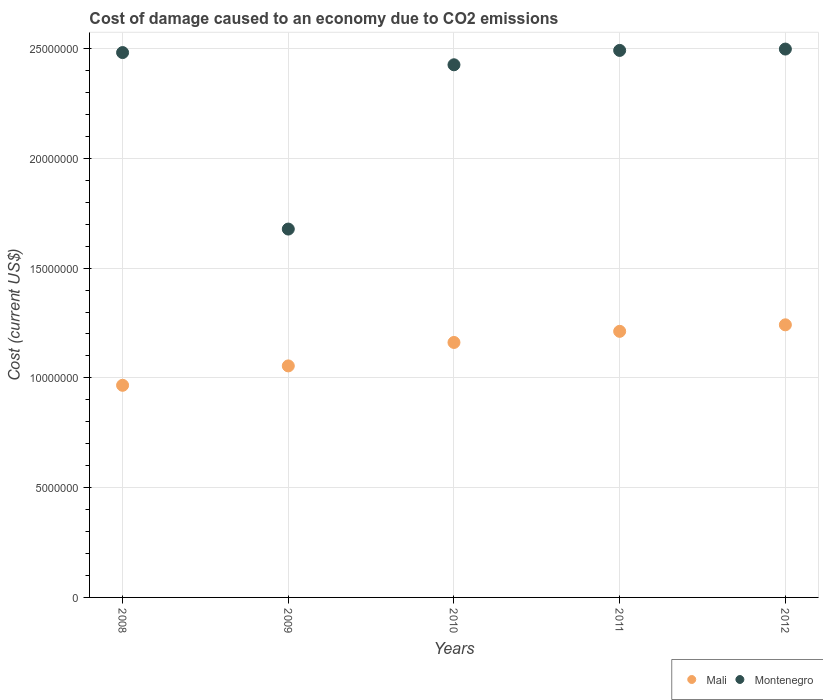How many different coloured dotlines are there?
Keep it short and to the point. 2. Is the number of dotlines equal to the number of legend labels?
Ensure brevity in your answer.  Yes. What is the cost of damage caused due to CO2 emissisons in Mali in 2012?
Keep it short and to the point. 1.24e+07. Across all years, what is the maximum cost of damage caused due to CO2 emissisons in Mali?
Ensure brevity in your answer.  1.24e+07. Across all years, what is the minimum cost of damage caused due to CO2 emissisons in Montenegro?
Provide a short and direct response. 1.68e+07. What is the total cost of damage caused due to CO2 emissisons in Montenegro in the graph?
Ensure brevity in your answer.  1.16e+08. What is the difference between the cost of damage caused due to CO2 emissisons in Montenegro in 2009 and that in 2012?
Make the answer very short. -8.20e+06. What is the difference between the cost of damage caused due to CO2 emissisons in Mali in 2011 and the cost of damage caused due to CO2 emissisons in Montenegro in 2009?
Your answer should be compact. -4.66e+06. What is the average cost of damage caused due to CO2 emissisons in Montenegro per year?
Offer a very short reply. 2.32e+07. In the year 2008, what is the difference between the cost of damage caused due to CO2 emissisons in Mali and cost of damage caused due to CO2 emissisons in Montenegro?
Give a very brief answer. -1.52e+07. In how many years, is the cost of damage caused due to CO2 emissisons in Mali greater than 9000000 US$?
Offer a very short reply. 5. What is the ratio of the cost of damage caused due to CO2 emissisons in Montenegro in 2008 to that in 2011?
Provide a short and direct response. 1. Is the cost of damage caused due to CO2 emissisons in Mali in 2008 less than that in 2009?
Make the answer very short. Yes. What is the difference between the highest and the second highest cost of damage caused due to CO2 emissisons in Montenegro?
Provide a succinct answer. 6.16e+04. What is the difference between the highest and the lowest cost of damage caused due to CO2 emissisons in Montenegro?
Offer a terse response. 8.20e+06. In how many years, is the cost of damage caused due to CO2 emissisons in Montenegro greater than the average cost of damage caused due to CO2 emissisons in Montenegro taken over all years?
Ensure brevity in your answer.  4. Does the cost of damage caused due to CO2 emissisons in Montenegro monotonically increase over the years?
Provide a short and direct response. No. Is the cost of damage caused due to CO2 emissisons in Montenegro strictly less than the cost of damage caused due to CO2 emissisons in Mali over the years?
Provide a succinct answer. No. How many dotlines are there?
Ensure brevity in your answer.  2. Are the values on the major ticks of Y-axis written in scientific E-notation?
Give a very brief answer. No. Does the graph contain any zero values?
Give a very brief answer. No. Does the graph contain grids?
Your answer should be compact. Yes. Where does the legend appear in the graph?
Ensure brevity in your answer.  Bottom right. How many legend labels are there?
Offer a terse response. 2. How are the legend labels stacked?
Provide a succinct answer. Horizontal. What is the title of the graph?
Keep it short and to the point. Cost of damage caused to an economy due to CO2 emissions. What is the label or title of the Y-axis?
Offer a terse response. Cost (current US$). What is the Cost (current US$) in Mali in 2008?
Your response must be concise. 9.66e+06. What is the Cost (current US$) in Montenegro in 2008?
Ensure brevity in your answer.  2.48e+07. What is the Cost (current US$) of Mali in 2009?
Your response must be concise. 1.05e+07. What is the Cost (current US$) of Montenegro in 2009?
Provide a succinct answer. 1.68e+07. What is the Cost (current US$) in Mali in 2010?
Keep it short and to the point. 1.16e+07. What is the Cost (current US$) in Montenegro in 2010?
Offer a very short reply. 2.43e+07. What is the Cost (current US$) in Mali in 2011?
Keep it short and to the point. 1.21e+07. What is the Cost (current US$) of Montenegro in 2011?
Keep it short and to the point. 2.49e+07. What is the Cost (current US$) in Mali in 2012?
Offer a terse response. 1.24e+07. What is the Cost (current US$) in Montenegro in 2012?
Ensure brevity in your answer.  2.50e+07. Across all years, what is the maximum Cost (current US$) of Mali?
Provide a short and direct response. 1.24e+07. Across all years, what is the maximum Cost (current US$) in Montenegro?
Offer a very short reply. 2.50e+07. Across all years, what is the minimum Cost (current US$) of Mali?
Give a very brief answer. 9.66e+06. Across all years, what is the minimum Cost (current US$) of Montenegro?
Provide a succinct answer. 1.68e+07. What is the total Cost (current US$) of Mali in the graph?
Offer a very short reply. 5.64e+07. What is the total Cost (current US$) of Montenegro in the graph?
Your answer should be compact. 1.16e+08. What is the difference between the Cost (current US$) of Mali in 2008 and that in 2009?
Offer a terse response. -8.83e+05. What is the difference between the Cost (current US$) of Montenegro in 2008 and that in 2009?
Provide a succinct answer. 8.04e+06. What is the difference between the Cost (current US$) of Mali in 2008 and that in 2010?
Your answer should be compact. -1.95e+06. What is the difference between the Cost (current US$) of Montenegro in 2008 and that in 2010?
Give a very brief answer. 5.56e+05. What is the difference between the Cost (current US$) in Mali in 2008 and that in 2011?
Provide a succinct answer. -2.46e+06. What is the difference between the Cost (current US$) in Montenegro in 2008 and that in 2011?
Offer a terse response. -9.83e+04. What is the difference between the Cost (current US$) in Mali in 2008 and that in 2012?
Provide a short and direct response. -2.75e+06. What is the difference between the Cost (current US$) in Montenegro in 2008 and that in 2012?
Provide a short and direct response. -1.60e+05. What is the difference between the Cost (current US$) in Mali in 2009 and that in 2010?
Offer a very short reply. -1.07e+06. What is the difference between the Cost (current US$) in Montenegro in 2009 and that in 2010?
Offer a terse response. -7.48e+06. What is the difference between the Cost (current US$) of Mali in 2009 and that in 2011?
Your answer should be very brief. -1.57e+06. What is the difference between the Cost (current US$) in Montenegro in 2009 and that in 2011?
Provide a succinct answer. -8.14e+06. What is the difference between the Cost (current US$) of Mali in 2009 and that in 2012?
Provide a succinct answer. -1.87e+06. What is the difference between the Cost (current US$) in Montenegro in 2009 and that in 2012?
Offer a terse response. -8.20e+06. What is the difference between the Cost (current US$) of Mali in 2010 and that in 2011?
Your answer should be compact. -5.07e+05. What is the difference between the Cost (current US$) in Montenegro in 2010 and that in 2011?
Provide a succinct answer. -6.55e+05. What is the difference between the Cost (current US$) of Mali in 2010 and that in 2012?
Offer a terse response. -8.03e+05. What is the difference between the Cost (current US$) in Montenegro in 2010 and that in 2012?
Make the answer very short. -7.16e+05. What is the difference between the Cost (current US$) of Mali in 2011 and that in 2012?
Provide a short and direct response. -2.96e+05. What is the difference between the Cost (current US$) in Montenegro in 2011 and that in 2012?
Make the answer very short. -6.16e+04. What is the difference between the Cost (current US$) in Mali in 2008 and the Cost (current US$) in Montenegro in 2009?
Offer a very short reply. -7.12e+06. What is the difference between the Cost (current US$) in Mali in 2008 and the Cost (current US$) in Montenegro in 2010?
Make the answer very short. -1.46e+07. What is the difference between the Cost (current US$) in Mali in 2008 and the Cost (current US$) in Montenegro in 2011?
Your answer should be compact. -1.53e+07. What is the difference between the Cost (current US$) in Mali in 2008 and the Cost (current US$) in Montenegro in 2012?
Ensure brevity in your answer.  -1.53e+07. What is the difference between the Cost (current US$) of Mali in 2009 and the Cost (current US$) of Montenegro in 2010?
Make the answer very short. -1.37e+07. What is the difference between the Cost (current US$) in Mali in 2009 and the Cost (current US$) in Montenegro in 2011?
Keep it short and to the point. -1.44e+07. What is the difference between the Cost (current US$) of Mali in 2009 and the Cost (current US$) of Montenegro in 2012?
Keep it short and to the point. -1.44e+07. What is the difference between the Cost (current US$) in Mali in 2010 and the Cost (current US$) in Montenegro in 2011?
Keep it short and to the point. -1.33e+07. What is the difference between the Cost (current US$) of Mali in 2010 and the Cost (current US$) of Montenegro in 2012?
Ensure brevity in your answer.  -1.34e+07. What is the difference between the Cost (current US$) of Mali in 2011 and the Cost (current US$) of Montenegro in 2012?
Your answer should be very brief. -1.29e+07. What is the average Cost (current US$) in Mali per year?
Provide a succinct answer. 1.13e+07. What is the average Cost (current US$) in Montenegro per year?
Give a very brief answer. 2.32e+07. In the year 2008, what is the difference between the Cost (current US$) of Mali and Cost (current US$) of Montenegro?
Offer a terse response. -1.52e+07. In the year 2009, what is the difference between the Cost (current US$) of Mali and Cost (current US$) of Montenegro?
Give a very brief answer. -6.23e+06. In the year 2010, what is the difference between the Cost (current US$) of Mali and Cost (current US$) of Montenegro?
Ensure brevity in your answer.  -1.26e+07. In the year 2011, what is the difference between the Cost (current US$) in Mali and Cost (current US$) in Montenegro?
Your answer should be very brief. -1.28e+07. In the year 2012, what is the difference between the Cost (current US$) of Mali and Cost (current US$) of Montenegro?
Your response must be concise. -1.26e+07. What is the ratio of the Cost (current US$) in Mali in 2008 to that in 2009?
Provide a succinct answer. 0.92. What is the ratio of the Cost (current US$) in Montenegro in 2008 to that in 2009?
Provide a short and direct response. 1.48. What is the ratio of the Cost (current US$) in Mali in 2008 to that in 2010?
Your answer should be compact. 0.83. What is the ratio of the Cost (current US$) of Montenegro in 2008 to that in 2010?
Offer a terse response. 1.02. What is the ratio of the Cost (current US$) of Mali in 2008 to that in 2011?
Provide a short and direct response. 0.8. What is the ratio of the Cost (current US$) of Montenegro in 2008 to that in 2011?
Ensure brevity in your answer.  1. What is the ratio of the Cost (current US$) of Mali in 2008 to that in 2012?
Your answer should be compact. 0.78. What is the ratio of the Cost (current US$) in Montenegro in 2008 to that in 2012?
Offer a terse response. 0.99. What is the ratio of the Cost (current US$) of Mali in 2009 to that in 2010?
Offer a very short reply. 0.91. What is the ratio of the Cost (current US$) in Montenegro in 2009 to that in 2010?
Ensure brevity in your answer.  0.69. What is the ratio of the Cost (current US$) in Mali in 2009 to that in 2011?
Provide a short and direct response. 0.87. What is the ratio of the Cost (current US$) in Montenegro in 2009 to that in 2011?
Your response must be concise. 0.67. What is the ratio of the Cost (current US$) in Mali in 2009 to that in 2012?
Make the answer very short. 0.85. What is the ratio of the Cost (current US$) in Montenegro in 2009 to that in 2012?
Offer a very short reply. 0.67. What is the ratio of the Cost (current US$) in Mali in 2010 to that in 2011?
Your response must be concise. 0.96. What is the ratio of the Cost (current US$) of Montenegro in 2010 to that in 2011?
Ensure brevity in your answer.  0.97. What is the ratio of the Cost (current US$) of Mali in 2010 to that in 2012?
Offer a terse response. 0.94. What is the ratio of the Cost (current US$) of Montenegro in 2010 to that in 2012?
Keep it short and to the point. 0.97. What is the ratio of the Cost (current US$) in Mali in 2011 to that in 2012?
Your response must be concise. 0.98. What is the difference between the highest and the second highest Cost (current US$) in Mali?
Keep it short and to the point. 2.96e+05. What is the difference between the highest and the second highest Cost (current US$) of Montenegro?
Offer a terse response. 6.16e+04. What is the difference between the highest and the lowest Cost (current US$) in Mali?
Offer a terse response. 2.75e+06. What is the difference between the highest and the lowest Cost (current US$) of Montenegro?
Make the answer very short. 8.20e+06. 